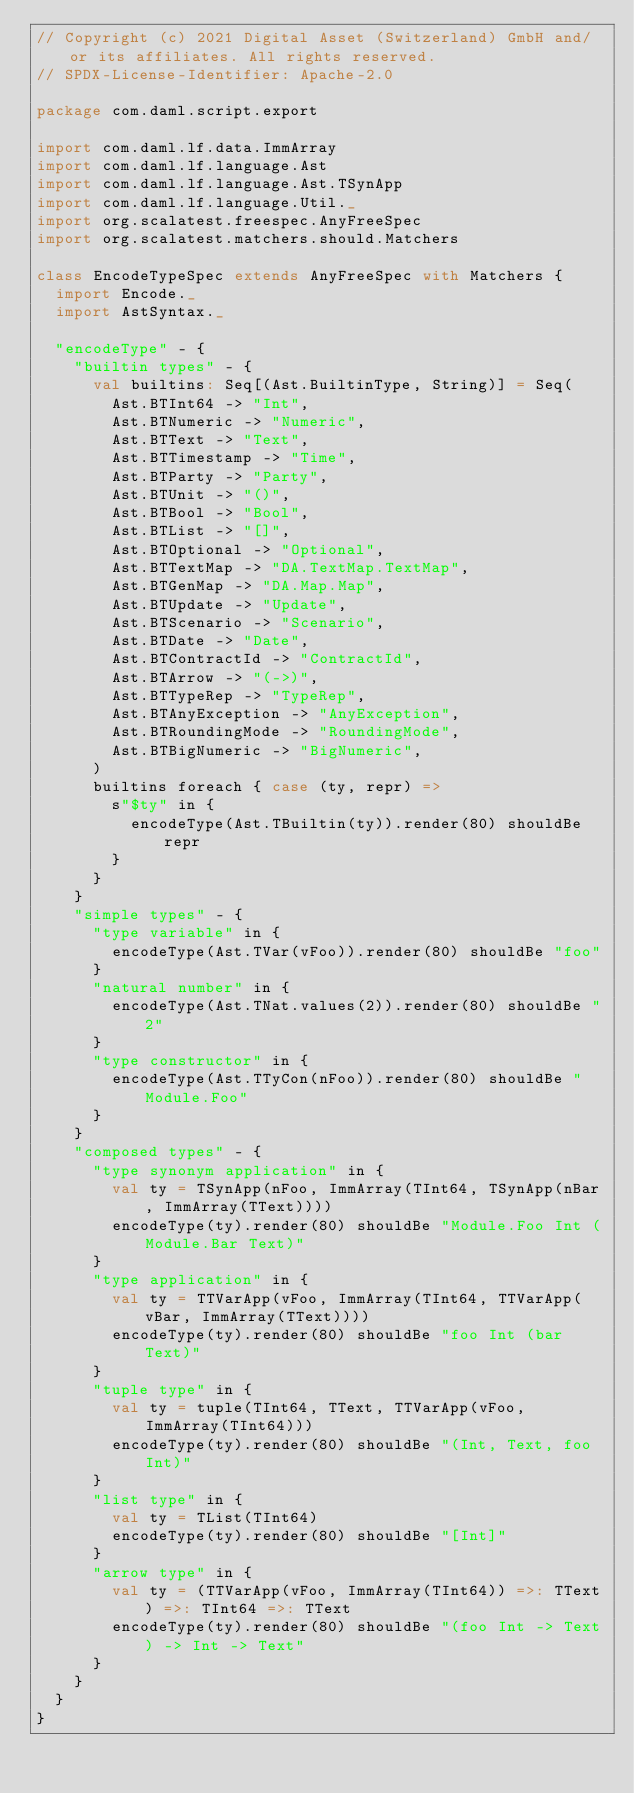Convert code to text. <code><loc_0><loc_0><loc_500><loc_500><_Scala_>// Copyright (c) 2021 Digital Asset (Switzerland) GmbH and/or its affiliates. All rights reserved.
// SPDX-License-Identifier: Apache-2.0

package com.daml.script.export

import com.daml.lf.data.ImmArray
import com.daml.lf.language.Ast
import com.daml.lf.language.Ast.TSynApp
import com.daml.lf.language.Util._
import org.scalatest.freespec.AnyFreeSpec
import org.scalatest.matchers.should.Matchers

class EncodeTypeSpec extends AnyFreeSpec with Matchers {
  import Encode._
  import AstSyntax._

  "encodeType" - {
    "builtin types" - {
      val builtins: Seq[(Ast.BuiltinType, String)] = Seq(
        Ast.BTInt64 -> "Int",
        Ast.BTNumeric -> "Numeric",
        Ast.BTText -> "Text",
        Ast.BTTimestamp -> "Time",
        Ast.BTParty -> "Party",
        Ast.BTUnit -> "()",
        Ast.BTBool -> "Bool",
        Ast.BTList -> "[]",
        Ast.BTOptional -> "Optional",
        Ast.BTTextMap -> "DA.TextMap.TextMap",
        Ast.BTGenMap -> "DA.Map.Map",
        Ast.BTUpdate -> "Update",
        Ast.BTScenario -> "Scenario",
        Ast.BTDate -> "Date",
        Ast.BTContractId -> "ContractId",
        Ast.BTArrow -> "(->)",
        Ast.BTTypeRep -> "TypeRep",
        Ast.BTAnyException -> "AnyException",
        Ast.BTRoundingMode -> "RoundingMode",
        Ast.BTBigNumeric -> "BigNumeric",
      )
      builtins foreach { case (ty, repr) =>
        s"$ty" in {
          encodeType(Ast.TBuiltin(ty)).render(80) shouldBe repr
        }
      }
    }
    "simple types" - {
      "type variable" in {
        encodeType(Ast.TVar(vFoo)).render(80) shouldBe "foo"
      }
      "natural number" in {
        encodeType(Ast.TNat.values(2)).render(80) shouldBe "2"
      }
      "type constructor" in {
        encodeType(Ast.TTyCon(nFoo)).render(80) shouldBe "Module.Foo"
      }
    }
    "composed types" - {
      "type synonym application" in {
        val ty = TSynApp(nFoo, ImmArray(TInt64, TSynApp(nBar, ImmArray(TText))))
        encodeType(ty).render(80) shouldBe "Module.Foo Int (Module.Bar Text)"
      }
      "type application" in {
        val ty = TTVarApp(vFoo, ImmArray(TInt64, TTVarApp(vBar, ImmArray(TText))))
        encodeType(ty).render(80) shouldBe "foo Int (bar Text)"
      }
      "tuple type" in {
        val ty = tuple(TInt64, TText, TTVarApp(vFoo, ImmArray(TInt64)))
        encodeType(ty).render(80) shouldBe "(Int, Text, foo Int)"
      }
      "list type" in {
        val ty = TList(TInt64)
        encodeType(ty).render(80) shouldBe "[Int]"
      }
      "arrow type" in {
        val ty = (TTVarApp(vFoo, ImmArray(TInt64)) =>: TText) =>: TInt64 =>: TText
        encodeType(ty).render(80) shouldBe "(foo Int -> Text) -> Int -> Text"
      }
    }
  }
}
</code> 